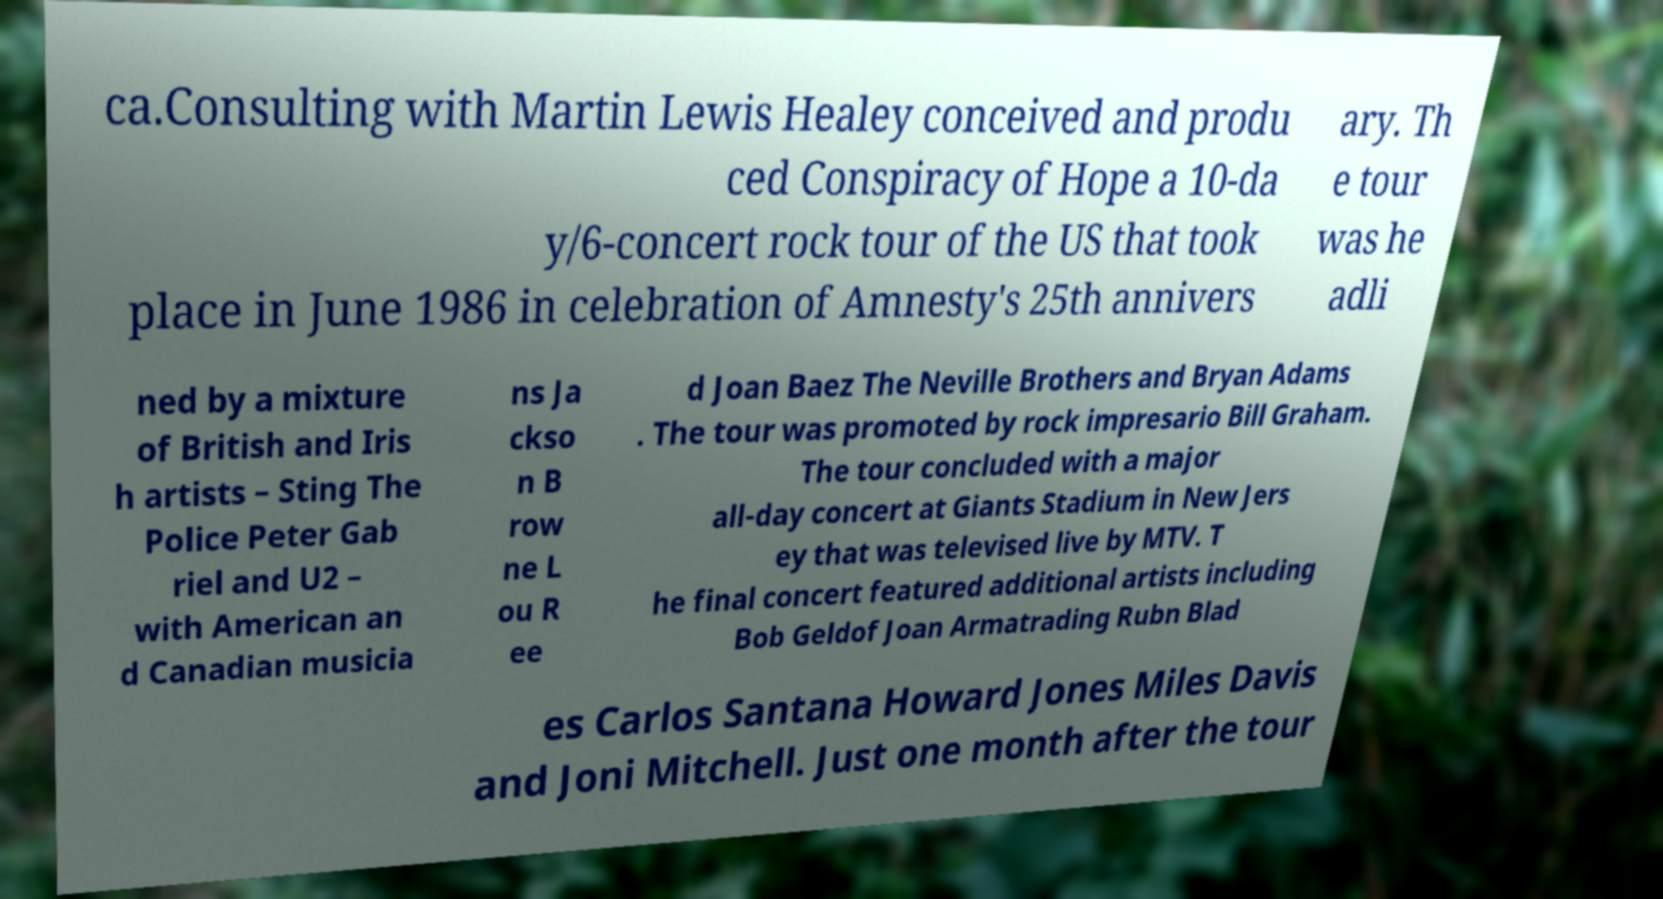Could you extract and type out the text from this image? ca.Consulting with Martin Lewis Healey conceived and produ ced Conspiracy of Hope a 10-da y/6-concert rock tour of the US that took place in June 1986 in celebration of Amnesty's 25th annivers ary. Th e tour was he adli ned by a mixture of British and Iris h artists – Sting The Police Peter Gab riel and U2 – with American an d Canadian musicia ns Ja ckso n B row ne L ou R ee d Joan Baez The Neville Brothers and Bryan Adams . The tour was promoted by rock impresario Bill Graham. The tour concluded with a major all-day concert at Giants Stadium in New Jers ey that was televised live by MTV. T he final concert featured additional artists including Bob Geldof Joan Armatrading Rubn Blad es Carlos Santana Howard Jones Miles Davis and Joni Mitchell. Just one month after the tour 